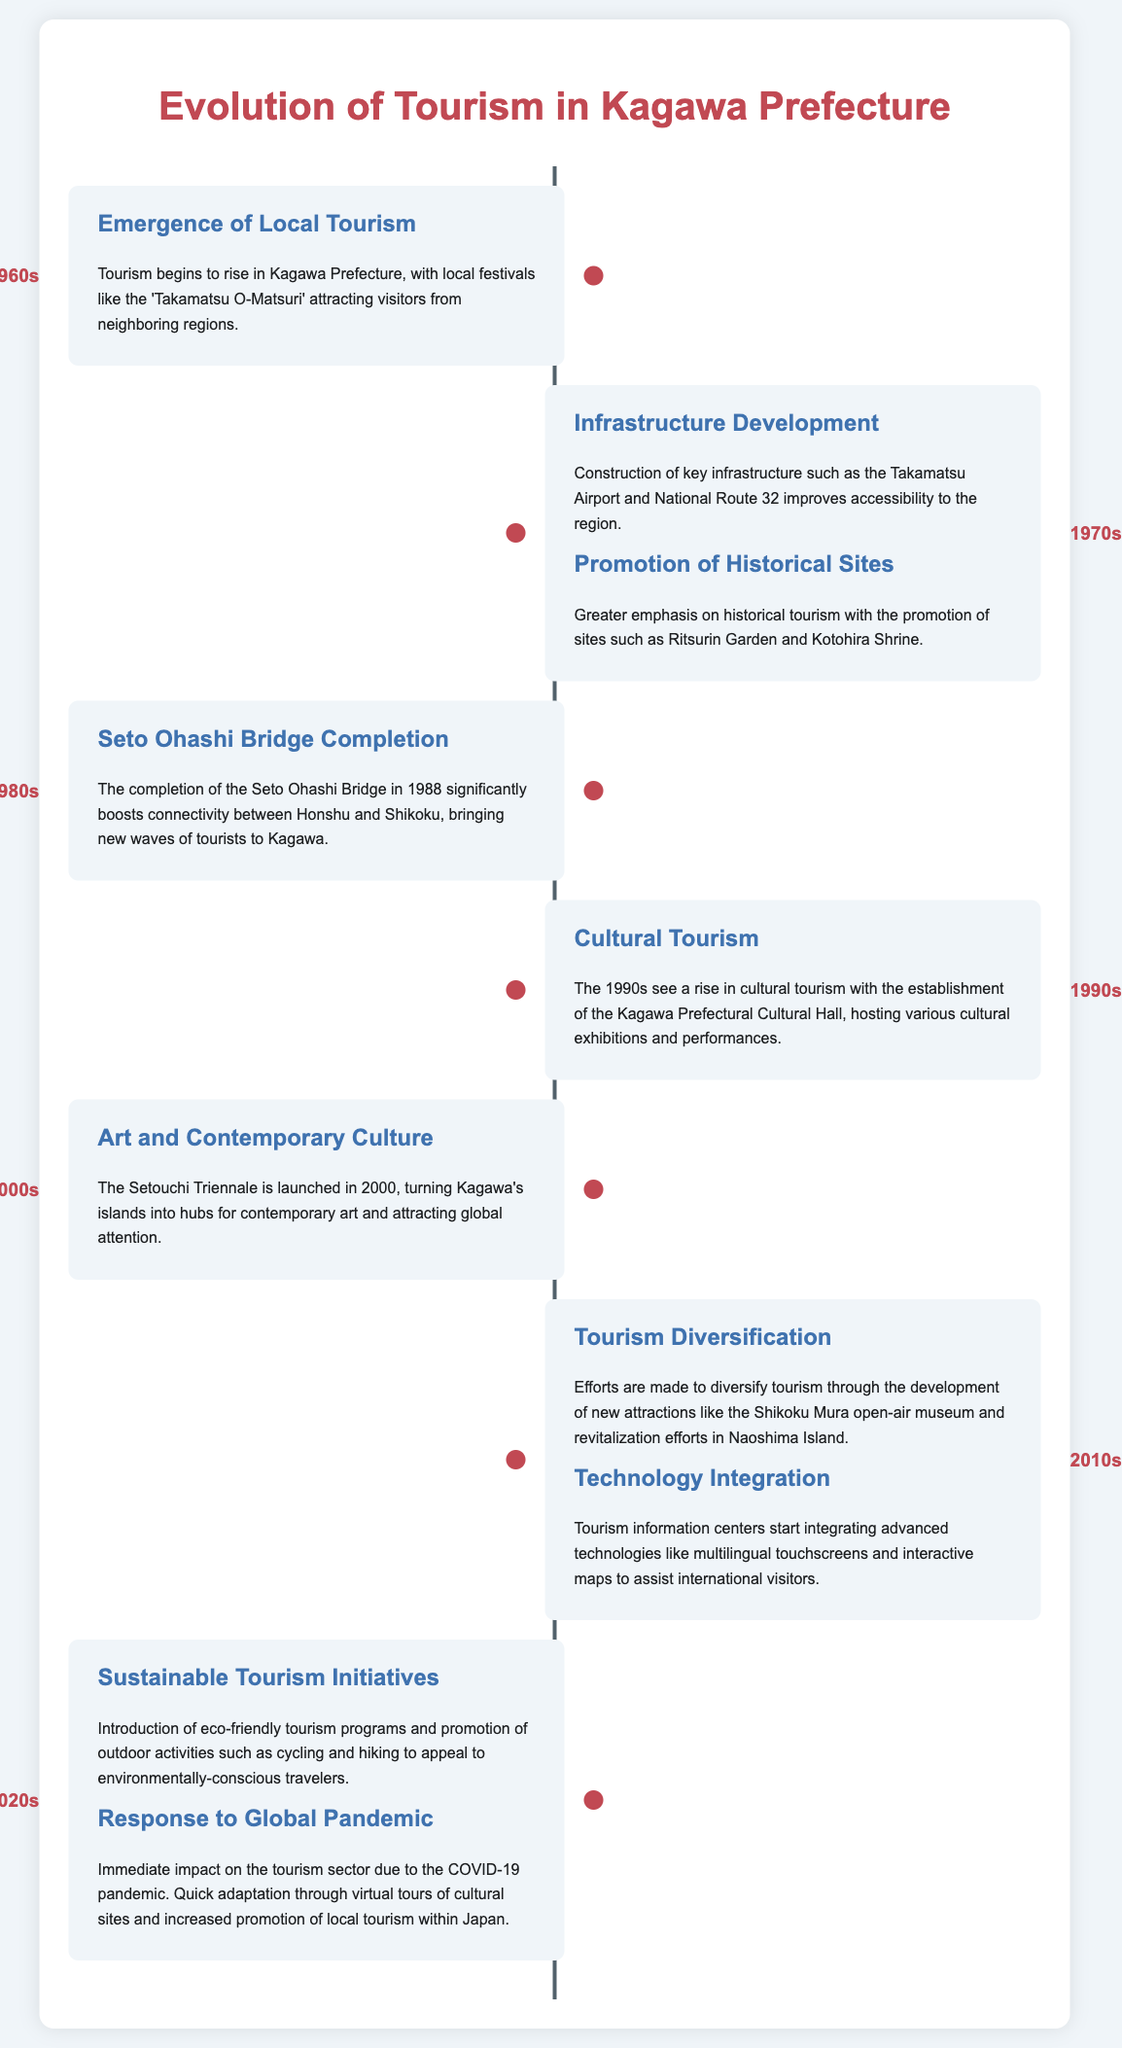What decade saw the emergence of local tourism? The emergence of local tourism in Kagawa Prefecture is noted in the 1960s.
Answer: 1960s What key infrastructure was constructed in the 1970s? The document mentions that Takamatsu Airport and National Route 32 were constructed to improve accessibility.
Answer: Takamatsu Airport Which significant bridge was completed in 1988? The timeline specifies the completion of the Seto Ohashi Bridge in 1988.
Answer: Seto Ohashi Bridge What major cultural event began in 2000? The launch of the Setouchi Triennale in 2000 is highlighted as a key event.
Answer: Setouchi Triennale What sustainable tourism initiatives were introduced in the 2020s? The document states that eco-friendly tourism programs and outdoor activities were introduced during this decade.
Answer: Eco-friendly tourism programs How did the tourism sector respond to the COVID-19 pandemic? Quick adaptation involved virtual tours of cultural sites and increased promotion of local tourism within Japan.
Answer: Virtual tours What type of tourism increased in the 1990s? Cultural tourism saw a rise in the 1990s according to the timeline.
Answer: Cultural tourism What was a focus of tourism diversification efforts in the 2010s? The development of new attractions, particularly the Shikoku Mura open-air museum, was emphasized.
Answer: Shikoku Mura open-air museum 